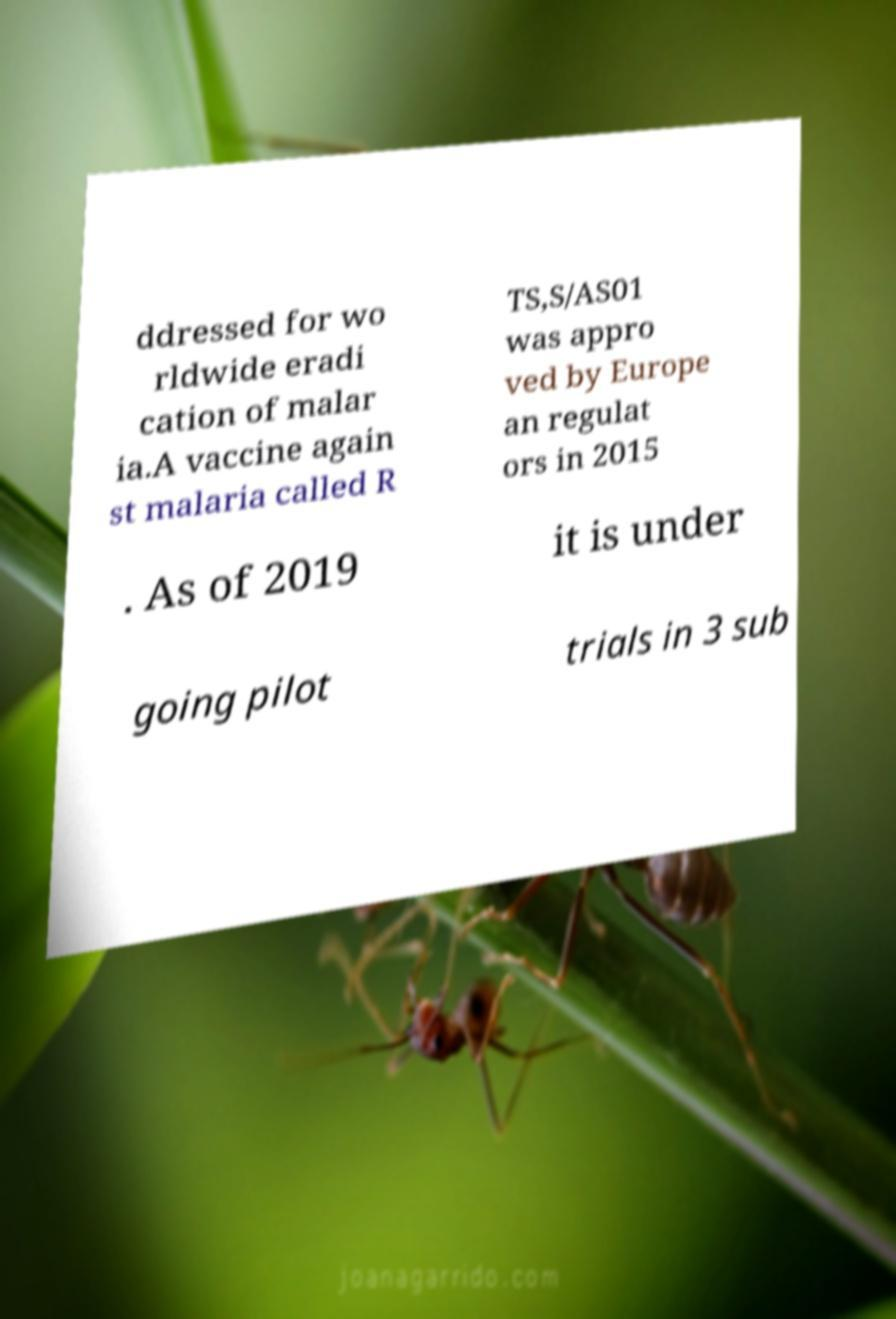Please read and relay the text visible in this image. What does it say? ddressed for wo rldwide eradi cation of malar ia.A vaccine again st malaria called R TS,S/AS01 was appro ved by Europe an regulat ors in 2015 . As of 2019 it is under going pilot trials in 3 sub 